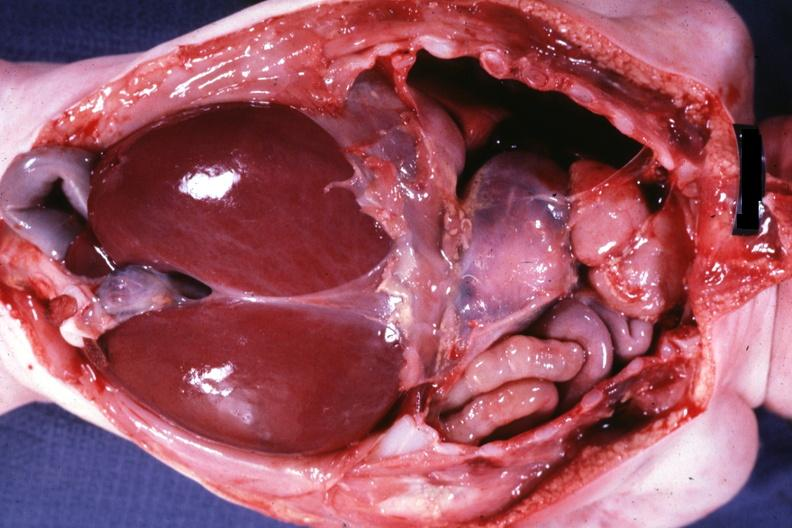does this image show opened infant body with abdominal viscera in right chest quite good?
Answer the question using a single word or phrase. Yes 